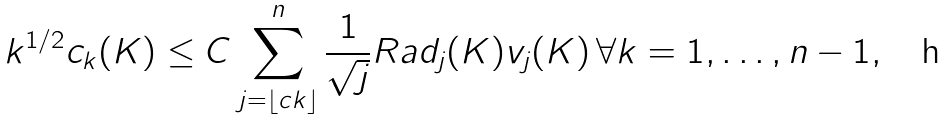Convert formula to latex. <formula><loc_0><loc_0><loc_500><loc_500>k ^ { 1 / 2 } c _ { k } ( K ) \leq C \sum _ { j = \lfloor c k \rfloor } ^ { n } \frac { 1 } { \sqrt { j } } R a d _ { j } ( K ) v _ { j } ( K ) \, \forall k = 1 , \dots , n - 1 ,</formula> 